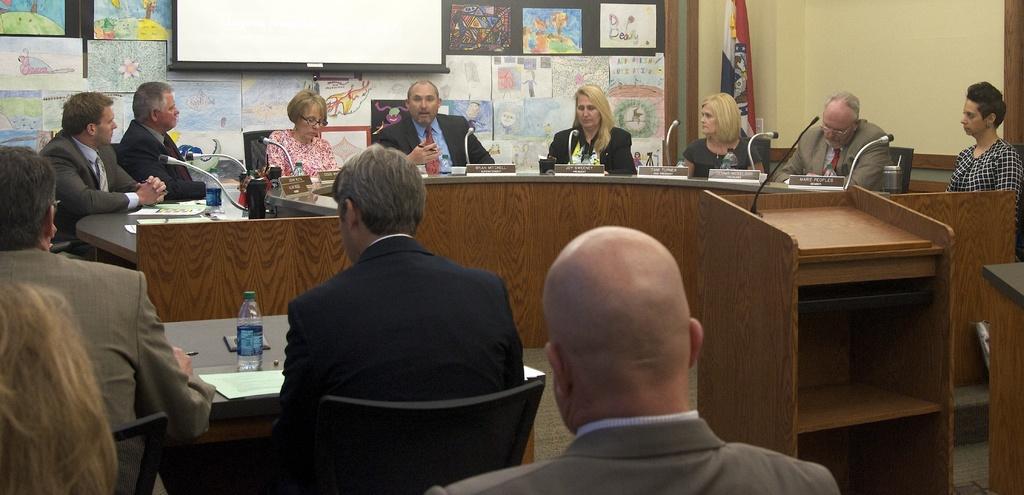Could you give a brief overview of what you see in this image? In this picture, there are many people sitting around a table. In front of there is a microphone. There are both men and women in the group. Some of them are sitting in the chair in front of them. 